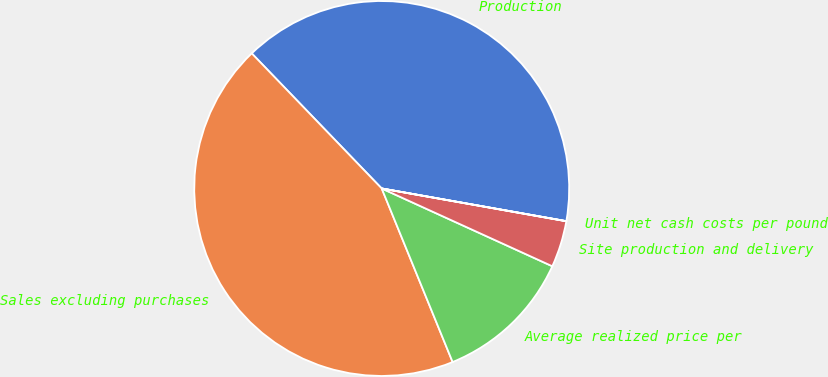Convert chart to OTSL. <chart><loc_0><loc_0><loc_500><loc_500><pie_chart><fcel>Production<fcel>Sales excluding purchases<fcel>Average realized price per<fcel>Site production and delivery<fcel>Unit net cash costs per pound<nl><fcel>39.98%<fcel>43.98%<fcel>12.02%<fcel>4.01%<fcel>0.01%<nl></chart> 